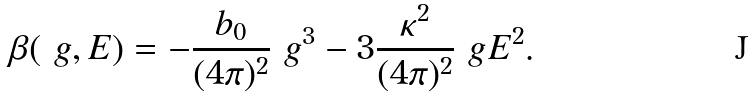<formula> <loc_0><loc_0><loc_500><loc_500>\beta ( \ g , E ) = - \frac { b _ { 0 } } { ( 4 \pi ) ^ { 2 } } \ g ^ { 3 } - 3 \frac { \kappa ^ { 2 } } { ( 4 \pi ) ^ { 2 } } \ g E ^ { 2 } .</formula> 